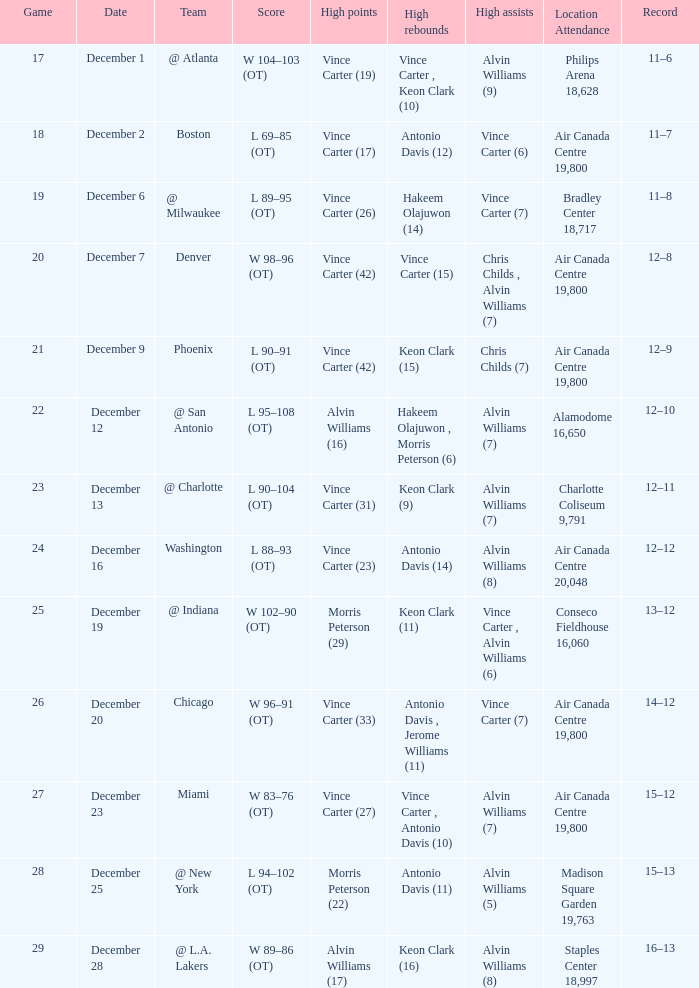Who scored the most points against Washington? Vince Carter (23). 